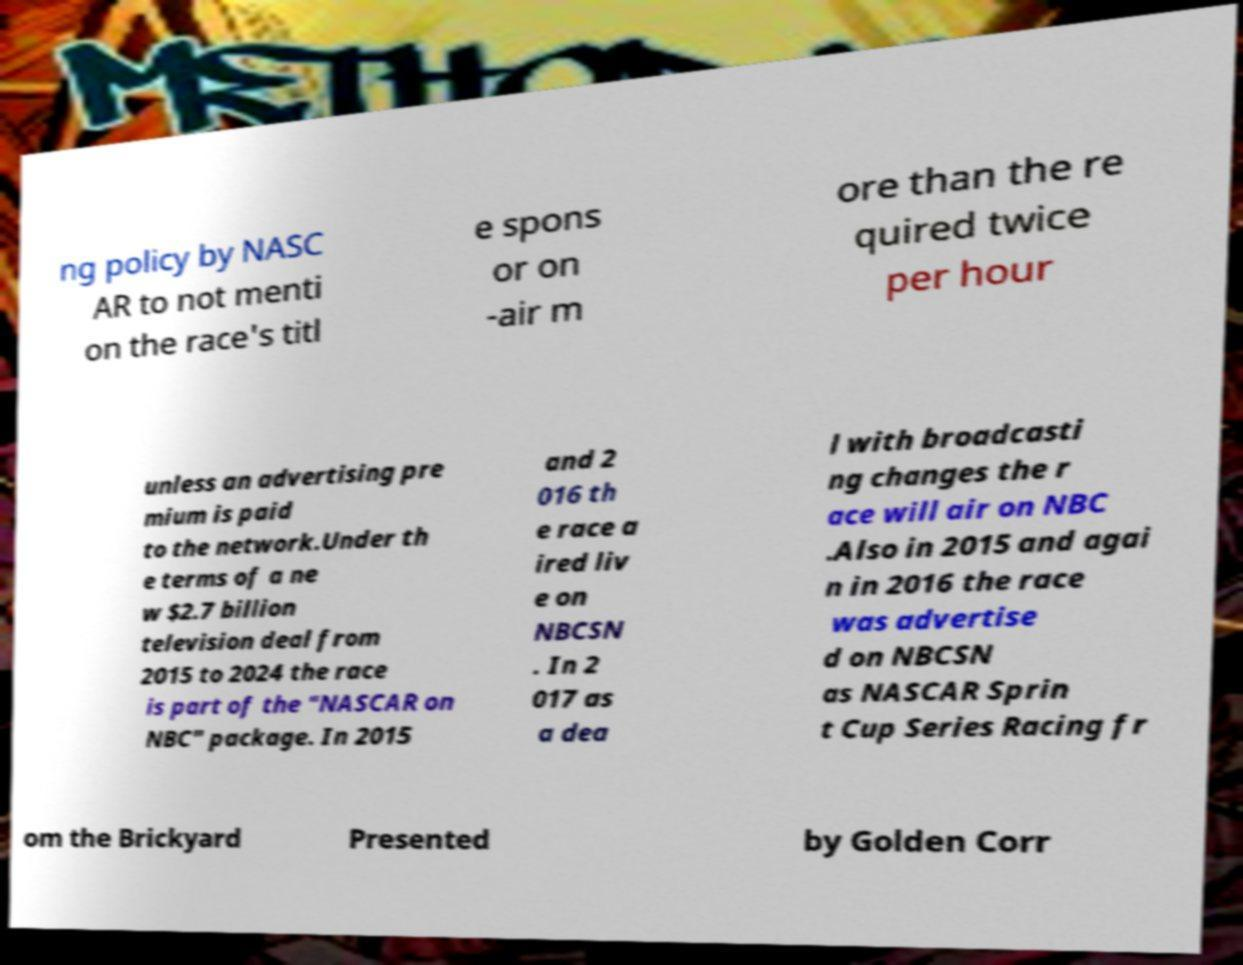There's text embedded in this image that I need extracted. Can you transcribe it verbatim? ng policy by NASC AR to not menti on the race's titl e spons or on -air m ore than the re quired twice per hour unless an advertising pre mium is paid to the network.Under th e terms of a ne w $2.7 billion television deal from 2015 to 2024 the race is part of the "NASCAR on NBC" package. In 2015 and 2 016 th e race a ired liv e on NBCSN . In 2 017 as a dea l with broadcasti ng changes the r ace will air on NBC .Also in 2015 and agai n in 2016 the race was advertise d on NBCSN as NASCAR Sprin t Cup Series Racing fr om the Brickyard Presented by Golden Corr 